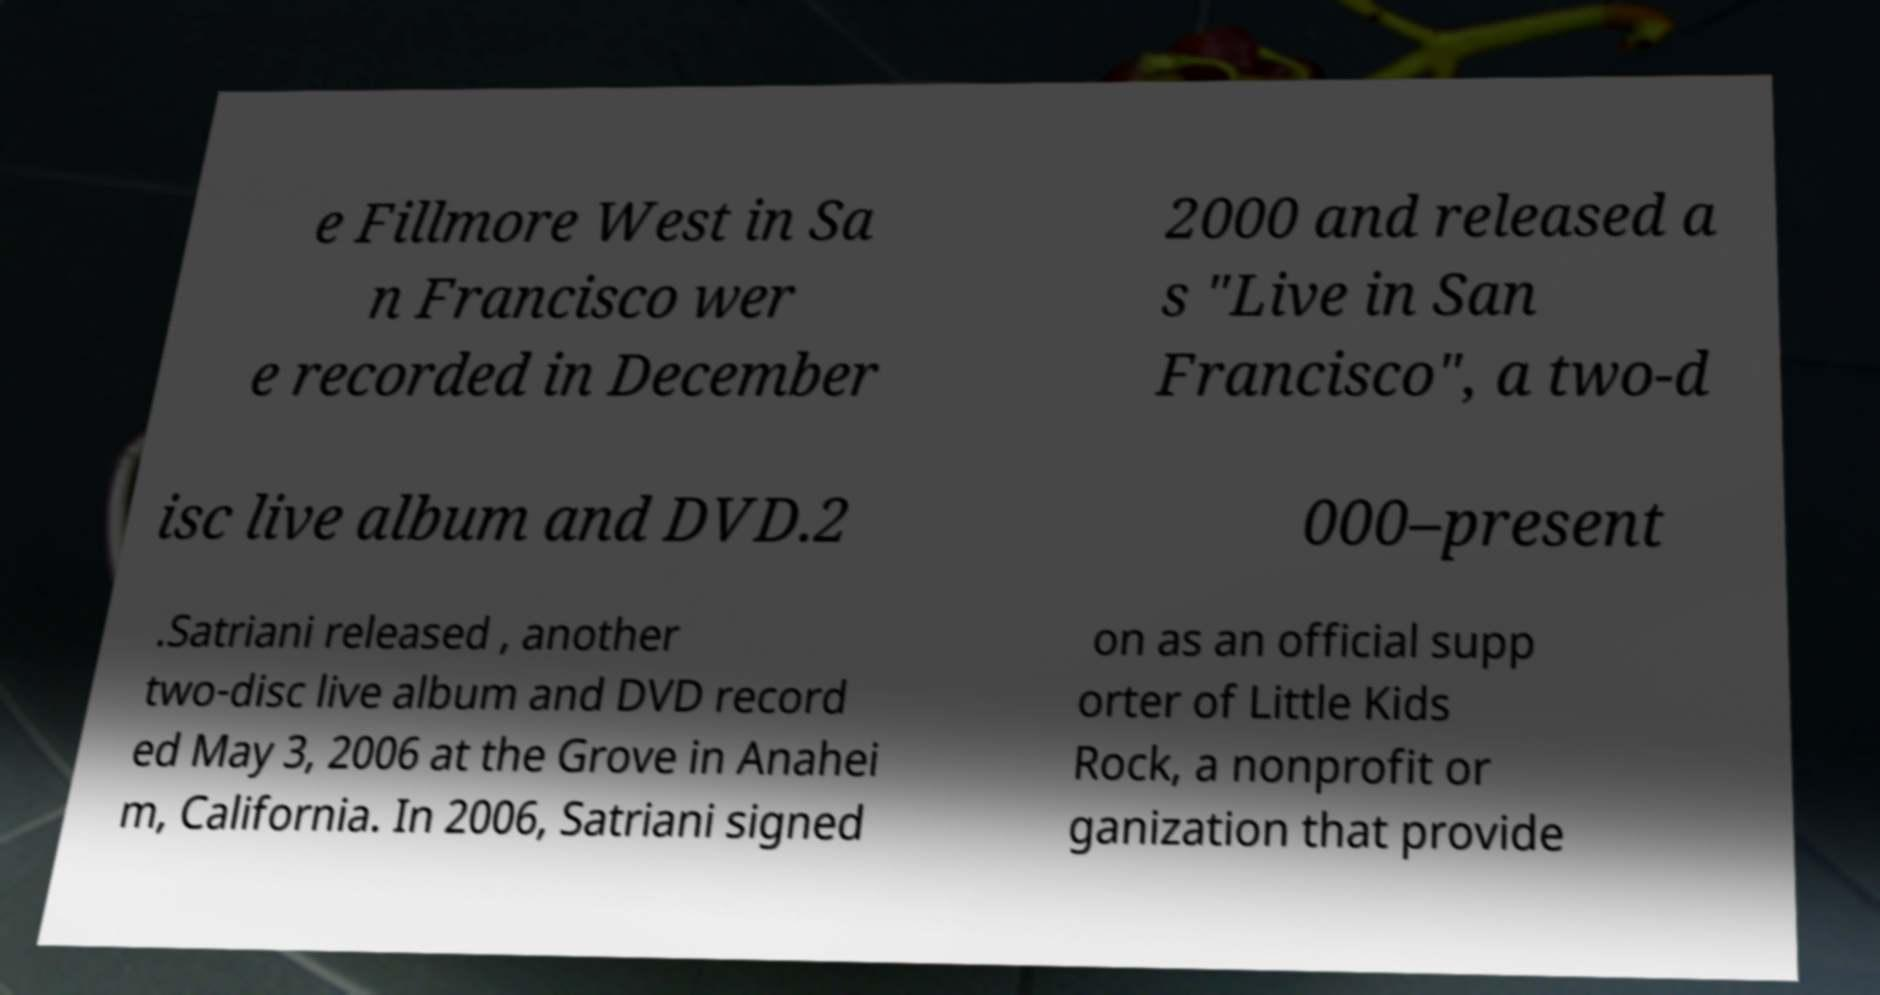Please read and relay the text visible in this image. What does it say? e Fillmore West in Sa n Francisco wer e recorded in December 2000 and released a s "Live in San Francisco", a two-d isc live album and DVD.2 000–present .Satriani released , another two-disc live album and DVD record ed May 3, 2006 at the Grove in Anahei m, California. In 2006, Satriani signed on as an official supp orter of Little Kids Rock, a nonprofit or ganization that provide 